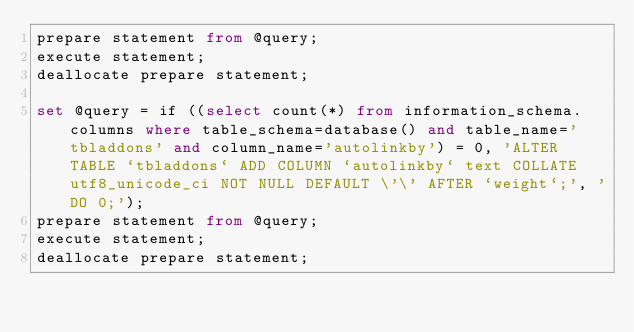Convert code to text. <code><loc_0><loc_0><loc_500><loc_500><_SQL_>prepare statement from @query;
execute statement;
deallocate prepare statement;

set @query = if ((select count(*) from information_schema.columns where table_schema=database() and table_name='tbladdons' and column_name='autolinkby') = 0, 'ALTER TABLE `tbladdons` ADD COLUMN `autolinkby` text COLLATE utf8_unicode_ci NOT NULL DEFAULT \'\' AFTER `weight`;', 'DO 0;');
prepare statement from @query;
execute statement;
deallocate prepare statement;
</code> 